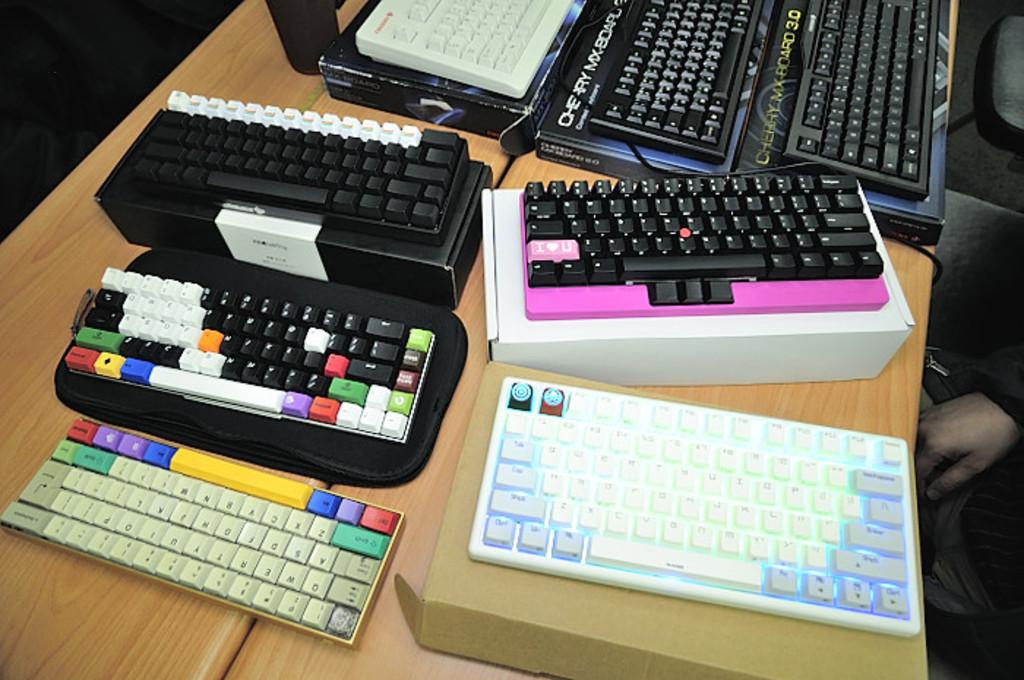What is the main object in the image? There is a table in the image. What is placed on the table? There are keyboards on the table. What type of operation is being performed on the stage in the image? There is no stage or operation present in the image; it only features a table with keyboards on it. 